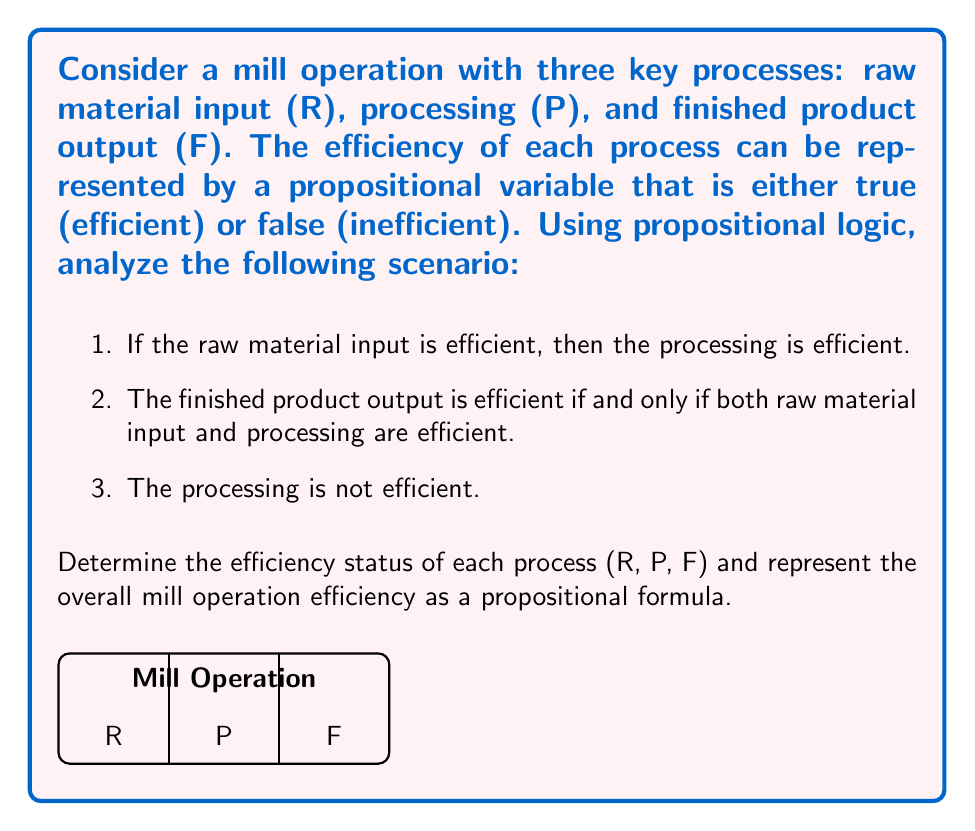Provide a solution to this math problem. Let's analyze this step-by-step using propositional logic:

1) We have three propositional variables:
   R: Raw material input is efficient
   P: Processing is efficient
   F: Finished product output is efficient

2) Given statements in logical notation:
   a) $R \implies P$
   b) $F \iff (R \land P)$
   c) $\lnot P$

3) From statement c, we know that P is false. This means processing is not efficient.

4) Given that P is false, and using the contrapositive of statement a $(R \implies P \equiv \lnot P \implies \lnot R)$, we can conclude that R must also be false. This means raw material input is not efficient.

5) Now, let's consider statement b. Since both R and P are false, $(R \land P)$ is false. Therefore, F must also be false for the biconditional to hold true.

6) We can represent the overall mill operation efficiency as a propositional formula:
   $E = R \land P \land F$

   Where E represents the overall efficiency of the mill operation. For the operation to be efficient, all three processes must be efficient.

7) In this case, since all variables are false, we have:
   $E = \text{false} \land \text{false} \land \text{false} = \text{false}$

This means the overall mill operation is not efficient.
Answer: R: false, P: false, F: false, $E = R \land P \land F = \text{false}$ 